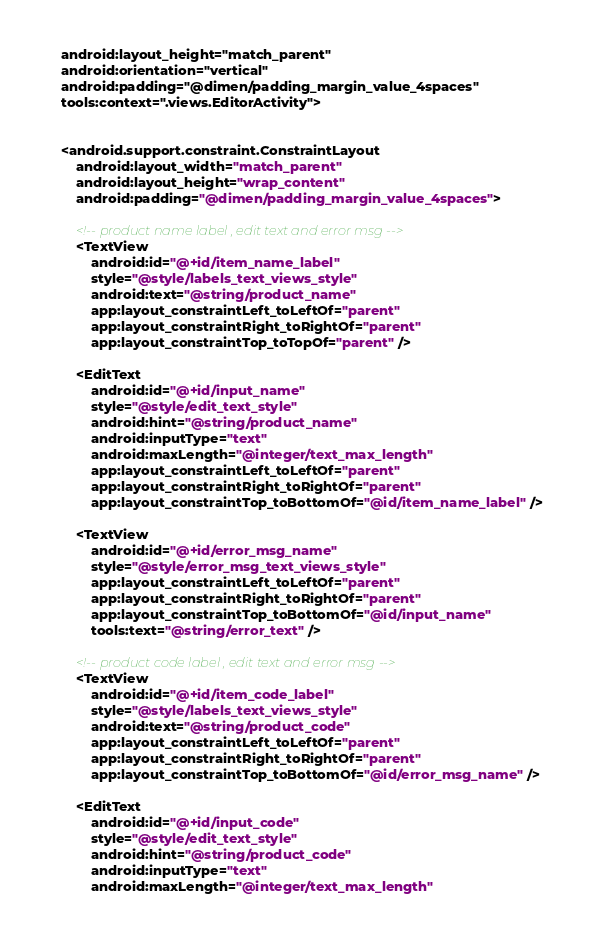<code> <loc_0><loc_0><loc_500><loc_500><_XML_>    android:layout_height="match_parent"
    android:orientation="vertical"
    android:padding="@dimen/padding_margin_value_4spaces"
    tools:context=".views.EditorActivity">


    <android.support.constraint.ConstraintLayout
        android:layout_width="match_parent"
        android:layout_height="wrap_content"
        android:padding="@dimen/padding_margin_value_4spaces">

        <!-- product name label , edit text and error msg -->
        <TextView
            android:id="@+id/item_name_label"
            style="@style/labels_text_views_style"
            android:text="@string/product_name"
            app:layout_constraintLeft_toLeftOf="parent"
            app:layout_constraintRight_toRightOf="parent"
            app:layout_constraintTop_toTopOf="parent" />

        <EditText
            android:id="@+id/input_name"
            style="@style/edit_text_style"
            android:hint="@string/product_name"
            android:inputType="text"
            android:maxLength="@integer/text_max_length"
            app:layout_constraintLeft_toLeftOf="parent"
            app:layout_constraintRight_toRightOf="parent"
            app:layout_constraintTop_toBottomOf="@id/item_name_label" />

        <TextView
            android:id="@+id/error_msg_name"
            style="@style/error_msg_text_views_style"
            app:layout_constraintLeft_toLeftOf="parent"
            app:layout_constraintRight_toRightOf="parent"
            app:layout_constraintTop_toBottomOf="@id/input_name"
            tools:text="@string/error_text" />

        <!-- product code label , edit text and error msg -->
        <TextView
            android:id="@+id/item_code_label"
            style="@style/labels_text_views_style"
            android:text="@string/product_code"
            app:layout_constraintLeft_toLeftOf="parent"
            app:layout_constraintRight_toRightOf="parent"
            app:layout_constraintTop_toBottomOf="@id/error_msg_name" />

        <EditText
            android:id="@+id/input_code"
            style="@style/edit_text_style"
            android:hint="@string/product_code"
            android:inputType="text"
            android:maxLength="@integer/text_max_length"</code> 